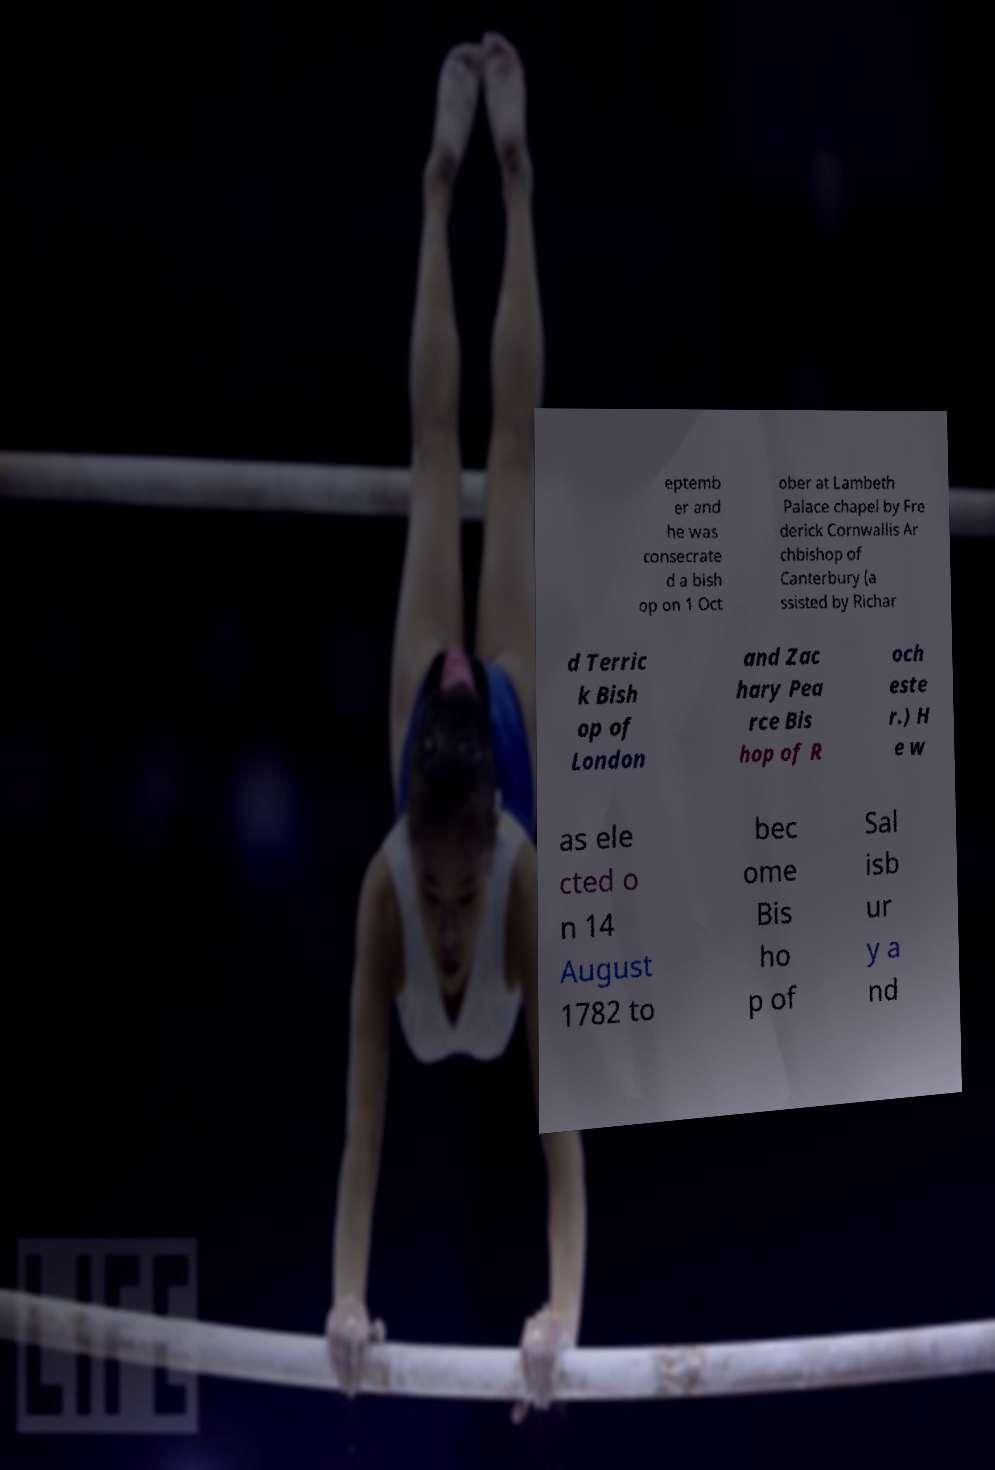For documentation purposes, I need the text within this image transcribed. Could you provide that? eptemb er and he was consecrate d a bish op on 1 Oct ober at Lambeth Palace chapel by Fre derick Cornwallis Ar chbishop of Canterbury (a ssisted by Richar d Terric k Bish op of London and Zac hary Pea rce Bis hop of R och este r.) H e w as ele cted o n 14 August 1782 to bec ome Bis ho p of Sal isb ur y a nd 